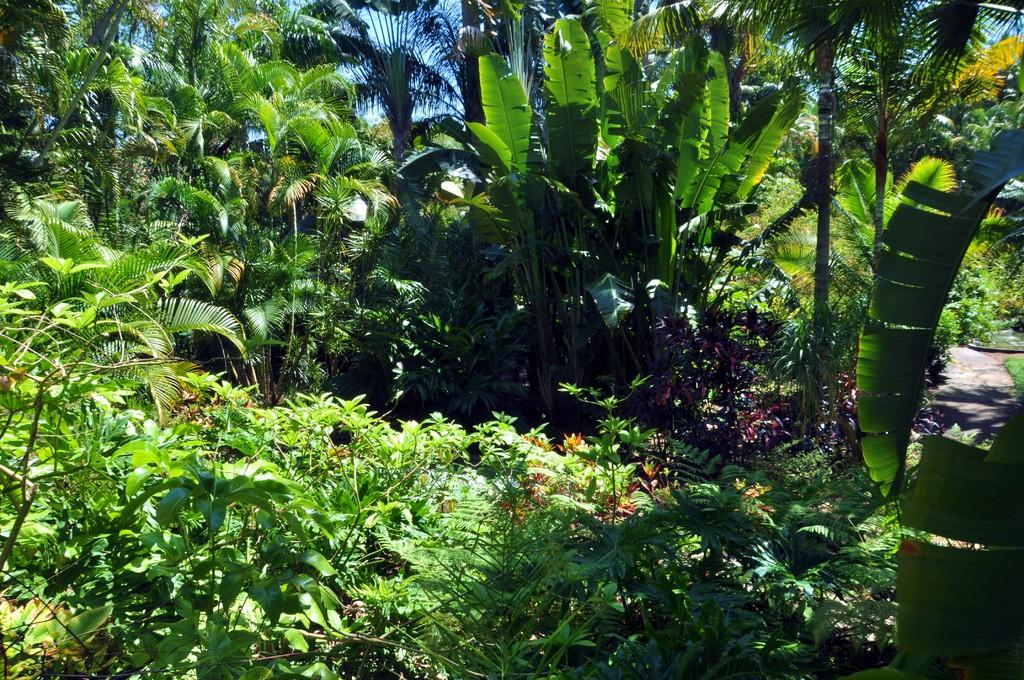What type of vegetation can be seen in the image? There are plants and trees in the image. What is visible beneath the vegetation in the image? The ground is visible in the image. What is visible above the vegetation in the image? The sky is visible in the image. How much milk is needed to water the plants in the image? There is no mention of milk or watering in the image, so it is not possible to determine how much milk might be needed. 